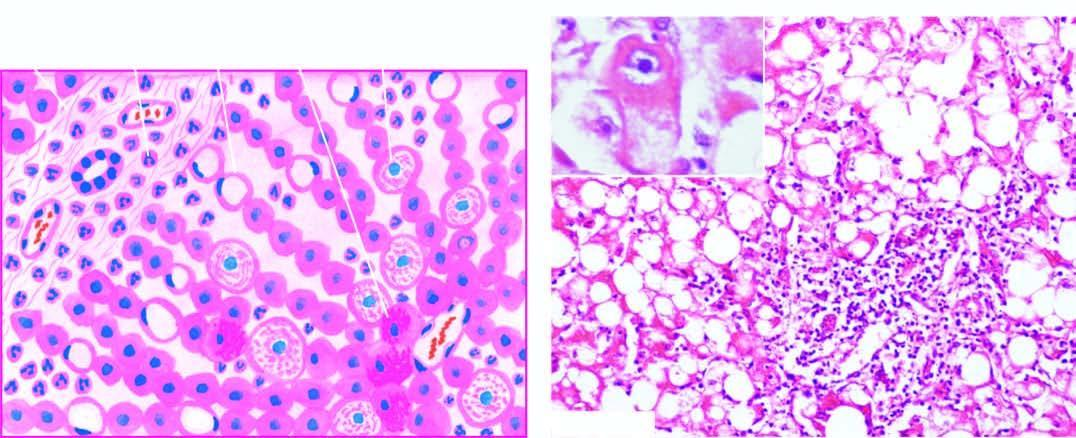re fatty change and clusters of neutrophils also present?
Answer the question using a single word or phrase. Yes 